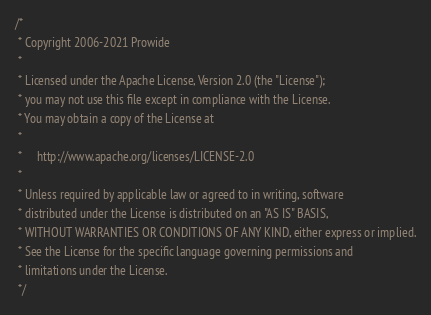<code> <loc_0><loc_0><loc_500><loc_500><_Java_>/*
 * Copyright 2006-2021 Prowide
 *
 * Licensed under the Apache License, Version 2.0 (the "License");
 * you may not use this file except in compliance with the License.
 * You may obtain a copy of the License at
 *
 *     http://www.apache.org/licenses/LICENSE-2.0
 *
 * Unless required by applicable law or agreed to in writing, software
 * distributed under the License is distributed on an "AS IS" BASIS,
 * WITHOUT WARRANTIES OR CONDITIONS OF ANY KIND, either express or implied.
 * See the License for the specific language governing permissions and
 * limitations under the License.
 */</code> 